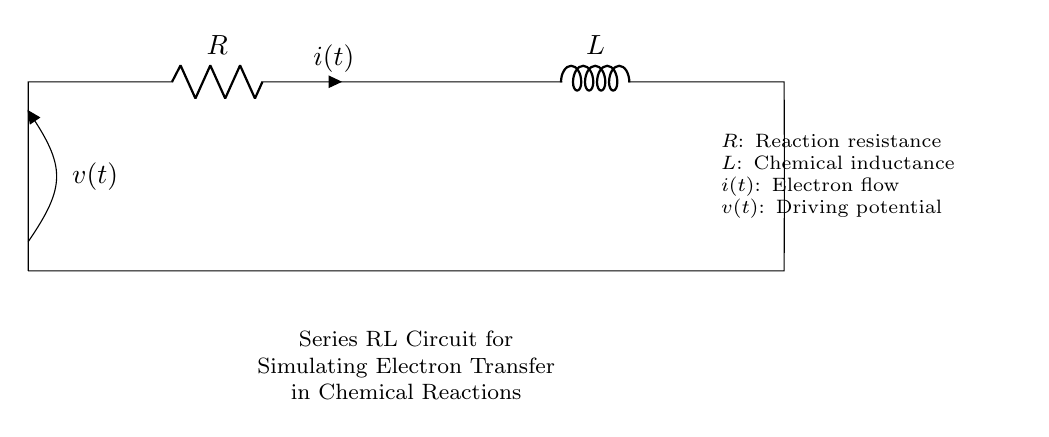What components are present in this circuit? The circuit consists of a resistor (R) and an inductor (L) connected in series. Each component is identified in the diagram, where R represents the reaction resistance and L indicates the chemical inductance.
Answer: Resistor and Inductor What does the symbol 'i' represent in this circuit? The symbol 'i' represents the current flowing through the circuit, specifically the electron flow at time t, which is critical for analyzing electron transfer processes in chemical reactions.
Answer: Electron flow Is the configuration of the circuit series or parallel? The circuit is arranged in series as the resistor and inductor are connected end to end, allowing the same current to flow through both components without any branching paths.
Answer: Series What is the voltage symbol in this circuit? The voltage is represented by 'v', which denotes the driving potential across the components in the circuit, indicating how much potential energy is provided to drive the current.
Answer: v(t) How does inductance affect the circuit's behavior over time? Inductance (L) influences the circuit's response to changes in current, resulting in a time-dependent behavior characterized by energy storage in the magnetic field, and the circuit exhibits a delay effect when the current changes.
Answer: Delays current changes What is the role of the resistor in this circuit? The resistor (R) represents the reaction resistance that dissipates energy in the form of heat, affecting the overall current flow and the efficiency of electron transfer during the chemical reaction simulation.
Answer: Energy dissipation What happens to the current when the circuit is first energized? When the circuit is initially energized, the current does not immediately reach its maximum value due to the inductor's opposition to changes in current, leading to a gradual increase over time as it builds up magnetic energy.
Answer: Current increases gradually 